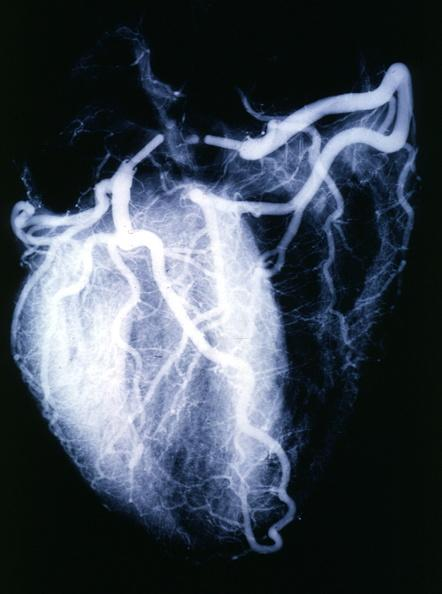where is this from?
Answer the question using a single word or phrase. Heart 